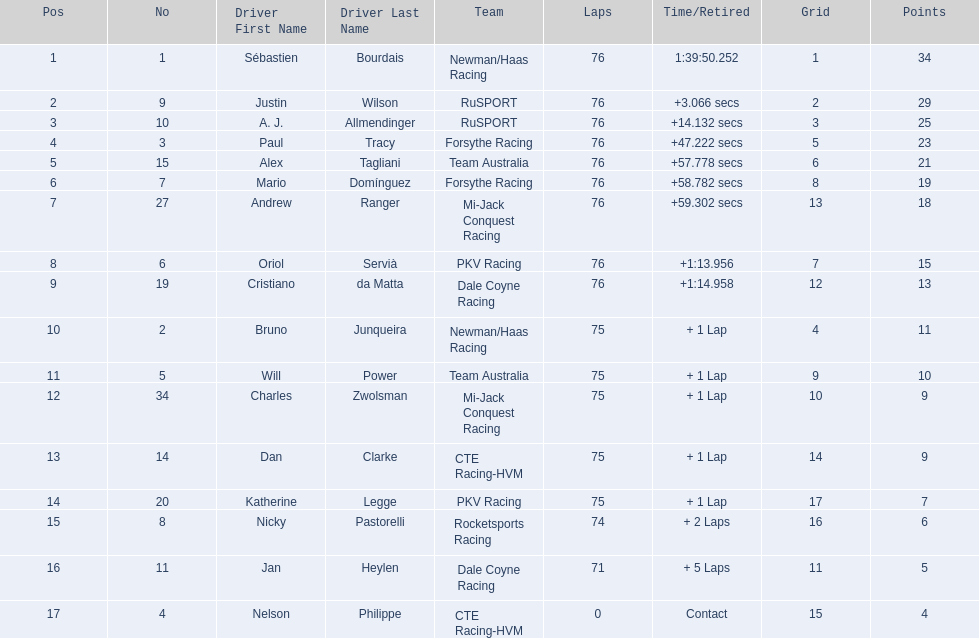What drivers took part in the 2006 tecate grand prix of monterrey? Sébastien Bourdais, Justin Wilson, A. J. Allmendinger, Paul Tracy, Alex Tagliani, Mario Domínguez, Andrew Ranger, Oriol Servià, Cristiano da Matta, Bruno Junqueira, Will Power, Charles Zwolsman, Dan Clarke, Katherine Legge, Nicky Pastorelli, Jan Heylen, Nelson Philippe. Which of those drivers scored the same amount of points as another driver? Charles Zwolsman, Dan Clarke. Who had the same amount of points as charles zwolsman? Dan Clarke. 